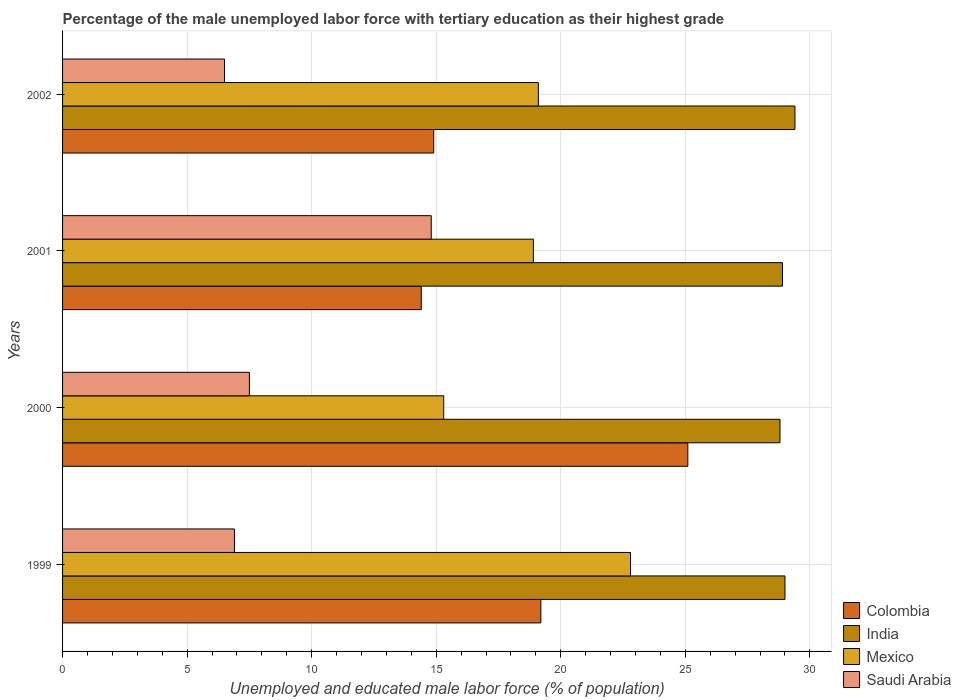Are the number of bars on each tick of the Y-axis equal?
Ensure brevity in your answer.  Yes. How many bars are there on the 3rd tick from the top?
Offer a very short reply. 4. How many bars are there on the 4th tick from the bottom?
Offer a very short reply. 4. In how many cases, is the number of bars for a given year not equal to the number of legend labels?
Your answer should be compact. 0. What is the percentage of the unemployed male labor force with tertiary education in India in 2000?
Make the answer very short. 28.8. Across all years, what is the maximum percentage of the unemployed male labor force with tertiary education in Saudi Arabia?
Ensure brevity in your answer.  14.8. Across all years, what is the minimum percentage of the unemployed male labor force with tertiary education in Saudi Arabia?
Offer a terse response. 6.5. In which year was the percentage of the unemployed male labor force with tertiary education in India minimum?
Ensure brevity in your answer.  2000. What is the total percentage of the unemployed male labor force with tertiary education in Colombia in the graph?
Offer a very short reply. 73.6. What is the difference between the percentage of the unemployed male labor force with tertiary education in Mexico in 2001 and that in 2002?
Make the answer very short. -0.2. What is the difference between the percentage of the unemployed male labor force with tertiary education in Colombia in 2000 and the percentage of the unemployed male labor force with tertiary education in India in 1999?
Your answer should be compact. -3.9. What is the average percentage of the unemployed male labor force with tertiary education in Saudi Arabia per year?
Provide a succinct answer. 8.93. In the year 2001, what is the difference between the percentage of the unemployed male labor force with tertiary education in Colombia and percentage of the unemployed male labor force with tertiary education in Saudi Arabia?
Your answer should be compact. -0.4. What is the ratio of the percentage of the unemployed male labor force with tertiary education in India in 2001 to that in 2002?
Your response must be concise. 0.98. Is the percentage of the unemployed male labor force with tertiary education in Saudi Arabia in 1999 less than that in 2000?
Your answer should be compact. Yes. What is the difference between the highest and the second highest percentage of the unemployed male labor force with tertiary education in Colombia?
Keep it short and to the point. 5.9. What is the difference between the highest and the lowest percentage of the unemployed male labor force with tertiary education in Mexico?
Your answer should be compact. 7.5. In how many years, is the percentage of the unemployed male labor force with tertiary education in Colombia greater than the average percentage of the unemployed male labor force with tertiary education in Colombia taken over all years?
Provide a short and direct response. 2. Is the sum of the percentage of the unemployed male labor force with tertiary education in India in 2001 and 2002 greater than the maximum percentage of the unemployed male labor force with tertiary education in Saudi Arabia across all years?
Ensure brevity in your answer.  Yes. Is it the case that in every year, the sum of the percentage of the unemployed male labor force with tertiary education in Mexico and percentage of the unemployed male labor force with tertiary education in Saudi Arabia is greater than the sum of percentage of the unemployed male labor force with tertiary education in Colombia and percentage of the unemployed male labor force with tertiary education in India?
Offer a very short reply. Yes. What does the 3rd bar from the top in 2001 represents?
Provide a short and direct response. India. What does the 1st bar from the bottom in 2001 represents?
Your response must be concise. Colombia. Is it the case that in every year, the sum of the percentage of the unemployed male labor force with tertiary education in Mexico and percentage of the unemployed male labor force with tertiary education in Colombia is greater than the percentage of the unemployed male labor force with tertiary education in Saudi Arabia?
Give a very brief answer. Yes. How many bars are there?
Provide a short and direct response. 16. Are the values on the major ticks of X-axis written in scientific E-notation?
Your answer should be very brief. No. Does the graph contain grids?
Offer a terse response. Yes. How are the legend labels stacked?
Provide a short and direct response. Vertical. What is the title of the graph?
Your answer should be compact. Percentage of the male unemployed labor force with tertiary education as their highest grade. What is the label or title of the X-axis?
Your answer should be very brief. Unemployed and educated male labor force (% of population). What is the label or title of the Y-axis?
Your answer should be very brief. Years. What is the Unemployed and educated male labor force (% of population) in Colombia in 1999?
Provide a short and direct response. 19.2. What is the Unemployed and educated male labor force (% of population) in Mexico in 1999?
Ensure brevity in your answer.  22.8. What is the Unemployed and educated male labor force (% of population) of Saudi Arabia in 1999?
Keep it short and to the point. 6.9. What is the Unemployed and educated male labor force (% of population) in Colombia in 2000?
Your response must be concise. 25.1. What is the Unemployed and educated male labor force (% of population) of India in 2000?
Offer a terse response. 28.8. What is the Unemployed and educated male labor force (% of population) in Mexico in 2000?
Make the answer very short. 15.3. What is the Unemployed and educated male labor force (% of population) in Saudi Arabia in 2000?
Your answer should be compact. 7.5. What is the Unemployed and educated male labor force (% of population) in Colombia in 2001?
Offer a very short reply. 14.4. What is the Unemployed and educated male labor force (% of population) of India in 2001?
Your answer should be very brief. 28.9. What is the Unemployed and educated male labor force (% of population) of Mexico in 2001?
Offer a very short reply. 18.9. What is the Unemployed and educated male labor force (% of population) of Saudi Arabia in 2001?
Offer a terse response. 14.8. What is the Unemployed and educated male labor force (% of population) in Colombia in 2002?
Give a very brief answer. 14.9. What is the Unemployed and educated male labor force (% of population) of India in 2002?
Provide a succinct answer. 29.4. What is the Unemployed and educated male labor force (% of population) in Mexico in 2002?
Keep it short and to the point. 19.1. What is the Unemployed and educated male labor force (% of population) in Saudi Arabia in 2002?
Ensure brevity in your answer.  6.5. Across all years, what is the maximum Unemployed and educated male labor force (% of population) in Colombia?
Give a very brief answer. 25.1. Across all years, what is the maximum Unemployed and educated male labor force (% of population) of India?
Your answer should be compact. 29.4. Across all years, what is the maximum Unemployed and educated male labor force (% of population) of Mexico?
Your answer should be very brief. 22.8. Across all years, what is the maximum Unemployed and educated male labor force (% of population) of Saudi Arabia?
Ensure brevity in your answer.  14.8. Across all years, what is the minimum Unemployed and educated male labor force (% of population) in Colombia?
Provide a short and direct response. 14.4. Across all years, what is the minimum Unemployed and educated male labor force (% of population) of India?
Ensure brevity in your answer.  28.8. Across all years, what is the minimum Unemployed and educated male labor force (% of population) of Mexico?
Ensure brevity in your answer.  15.3. What is the total Unemployed and educated male labor force (% of population) in Colombia in the graph?
Offer a very short reply. 73.6. What is the total Unemployed and educated male labor force (% of population) of India in the graph?
Ensure brevity in your answer.  116.1. What is the total Unemployed and educated male labor force (% of population) in Mexico in the graph?
Ensure brevity in your answer.  76.1. What is the total Unemployed and educated male labor force (% of population) in Saudi Arabia in the graph?
Give a very brief answer. 35.7. What is the difference between the Unemployed and educated male labor force (% of population) in Saudi Arabia in 1999 and that in 2000?
Your answer should be compact. -0.6. What is the difference between the Unemployed and educated male labor force (% of population) in Colombia in 1999 and that in 2001?
Give a very brief answer. 4.8. What is the difference between the Unemployed and educated male labor force (% of population) of India in 1999 and that in 2001?
Provide a short and direct response. 0.1. What is the difference between the Unemployed and educated male labor force (% of population) of Saudi Arabia in 1999 and that in 2001?
Keep it short and to the point. -7.9. What is the difference between the Unemployed and educated male labor force (% of population) in Mexico in 1999 and that in 2002?
Provide a succinct answer. 3.7. What is the difference between the Unemployed and educated male labor force (% of population) of Mexico in 2000 and that in 2001?
Provide a short and direct response. -3.6. What is the difference between the Unemployed and educated male labor force (% of population) of Colombia in 2000 and that in 2002?
Your answer should be compact. 10.2. What is the difference between the Unemployed and educated male labor force (% of population) of India in 2000 and that in 2002?
Offer a terse response. -0.6. What is the difference between the Unemployed and educated male labor force (% of population) of Mexico in 2000 and that in 2002?
Your answer should be very brief. -3.8. What is the difference between the Unemployed and educated male labor force (% of population) in Colombia in 2001 and that in 2002?
Offer a terse response. -0.5. What is the difference between the Unemployed and educated male labor force (% of population) of India in 2001 and that in 2002?
Offer a very short reply. -0.5. What is the difference between the Unemployed and educated male labor force (% of population) of Mexico in 2001 and that in 2002?
Your response must be concise. -0.2. What is the difference between the Unemployed and educated male labor force (% of population) in Saudi Arabia in 2001 and that in 2002?
Your answer should be compact. 8.3. What is the difference between the Unemployed and educated male labor force (% of population) in Colombia in 1999 and the Unemployed and educated male labor force (% of population) in India in 2000?
Your answer should be compact. -9.6. What is the difference between the Unemployed and educated male labor force (% of population) of Colombia in 1999 and the Unemployed and educated male labor force (% of population) of Mexico in 2000?
Offer a terse response. 3.9. What is the difference between the Unemployed and educated male labor force (% of population) of Colombia in 1999 and the Unemployed and educated male labor force (% of population) of Saudi Arabia in 2000?
Keep it short and to the point. 11.7. What is the difference between the Unemployed and educated male labor force (% of population) of India in 1999 and the Unemployed and educated male labor force (% of population) of Mexico in 2000?
Provide a succinct answer. 13.7. What is the difference between the Unemployed and educated male labor force (% of population) in Mexico in 1999 and the Unemployed and educated male labor force (% of population) in Saudi Arabia in 2000?
Make the answer very short. 15.3. What is the difference between the Unemployed and educated male labor force (% of population) of Colombia in 1999 and the Unemployed and educated male labor force (% of population) of India in 2001?
Give a very brief answer. -9.7. What is the difference between the Unemployed and educated male labor force (% of population) of Colombia in 1999 and the Unemployed and educated male labor force (% of population) of Saudi Arabia in 2001?
Your answer should be compact. 4.4. What is the difference between the Unemployed and educated male labor force (% of population) of India in 1999 and the Unemployed and educated male labor force (% of population) of Mexico in 2001?
Offer a terse response. 10.1. What is the difference between the Unemployed and educated male labor force (% of population) in Mexico in 1999 and the Unemployed and educated male labor force (% of population) in Saudi Arabia in 2001?
Offer a very short reply. 8. What is the difference between the Unemployed and educated male labor force (% of population) of Colombia in 1999 and the Unemployed and educated male labor force (% of population) of Saudi Arabia in 2002?
Ensure brevity in your answer.  12.7. What is the difference between the Unemployed and educated male labor force (% of population) in India in 1999 and the Unemployed and educated male labor force (% of population) in Mexico in 2002?
Give a very brief answer. 9.9. What is the difference between the Unemployed and educated male labor force (% of population) in Mexico in 1999 and the Unemployed and educated male labor force (% of population) in Saudi Arabia in 2002?
Provide a succinct answer. 16.3. What is the difference between the Unemployed and educated male labor force (% of population) in Colombia in 2000 and the Unemployed and educated male labor force (% of population) in Mexico in 2001?
Give a very brief answer. 6.2. What is the difference between the Unemployed and educated male labor force (% of population) in Mexico in 2000 and the Unemployed and educated male labor force (% of population) in Saudi Arabia in 2001?
Provide a short and direct response. 0.5. What is the difference between the Unemployed and educated male labor force (% of population) in India in 2000 and the Unemployed and educated male labor force (% of population) in Mexico in 2002?
Offer a terse response. 9.7. What is the difference between the Unemployed and educated male labor force (% of population) of India in 2000 and the Unemployed and educated male labor force (% of population) of Saudi Arabia in 2002?
Give a very brief answer. 22.3. What is the difference between the Unemployed and educated male labor force (% of population) of Mexico in 2000 and the Unemployed and educated male labor force (% of population) of Saudi Arabia in 2002?
Give a very brief answer. 8.8. What is the difference between the Unemployed and educated male labor force (% of population) in Colombia in 2001 and the Unemployed and educated male labor force (% of population) in Mexico in 2002?
Provide a short and direct response. -4.7. What is the difference between the Unemployed and educated male labor force (% of population) in India in 2001 and the Unemployed and educated male labor force (% of population) in Saudi Arabia in 2002?
Offer a very short reply. 22.4. What is the difference between the Unemployed and educated male labor force (% of population) of Mexico in 2001 and the Unemployed and educated male labor force (% of population) of Saudi Arabia in 2002?
Provide a short and direct response. 12.4. What is the average Unemployed and educated male labor force (% of population) of India per year?
Make the answer very short. 29.02. What is the average Unemployed and educated male labor force (% of population) in Mexico per year?
Offer a terse response. 19.02. What is the average Unemployed and educated male labor force (% of population) in Saudi Arabia per year?
Ensure brevity in your answer.  8.93. In the year 1999, what is the difference between the Unemployed and educated male labor force (% of population) of Colombia and Unemployed and educated male labor force (% of population) of India?
Give a very brief answer. -9.8. In the year 1999, what is the difference between the Unemployed and educated male labor force (% of population) in Colombia and Unemployed and educated male labor force (% of population) in Saudi Arabia?
Provide a short and direct response. 12.3. In the year 1999, what is the difference between the Unemployed and educated male labor force (% of population) of India and Unemployed and educated male labor force (% of population) of Saudi Arabia?
Offer a terse response. 22.1. In the year 2000, what is the difference between the Unemployed and educated male labor force (% of population) of Colombia and Unemployed and educated male labor force (% of population) of Saudi Arabia?
Your response must be concise. 17.6. In the year 2000, what is the difference between the Unemployed and educated male labor force (% of population) in India and Unemployed and educated male labor force (% of population) in Saudi Arabia?
Your answer should be very brief. 21.3. In the year 2002, what is the difference between the Unemployed and educated male labor force (% of population) in Colombia and Unemployed and educated male labor force (% of population) in India?
Keep it short and to the point. -14.5. In the year 2002, what is the difference between the Unemployed and educated male labor force (% of population) of Colombia and Unemployed and educated male labor force (% of population) of Mexico?
Your answer should be very brief. -4.2. In the year 2002, what is the difference between the Unemployed and educated male labor force (% of population) in Colombia and Unemployed and educated male labor force (% of population) in Saudi Arabia?
Provide a succinct answer. 8.4. In the year 2002, what is the difference between the Unemployed and educated male labor force (% of population) of India and Unemployed and educated male labor force (% of population) of Mexico?
Your answer should be compact. 10.3. In the year 2002, what is the difference between the Unemployed and educated male labor force (% of population) in India and Unemployed and educated male labor force (% of population) in Saudi Arabia?
Your answer should be compact. 22.9. In the year 2002, what is the difference between the Unemployed and educated male labor force (% of population) in Mexico and Unemployed and educated male labor force (% of population) in Saudi Arabia?
Keep it short and to the point. 12.6. What is the ratio of the Unemployed and educated male labor force (% of population) of Colombia in 1999 to that in 2000?
Offer a terse response. 0.76. What is the ratio of the Unemployed and educated male labor force (% of population) in Mexico in 1999 to that in 2000?
Provide a short and direct response. 1.49. What is the ratio of the Unemployed and educated male labor force (% of population) of Colombia in 1999 to that in 2001?
Keep it short and to the point. 1.33. What is the ratio of the Unemployed and educated male labor force (% of population) of Mexico in 1999 to that in 2001?
Ensure brevity in your answer.  1.21. What is the ratio of the Unemployed and educated male labor force (% of population) in Saudi Arabia in 1999 to that in 2001?
Make the answer very short. 0.47. What is the ratio of the Unemployed and educated male labor force (% of population) of Colombia in 1999 to that in 2002?
Offer a terse response. 1.29. What is the ratio of the Unemployed and educated male labor force (% of population) in India in 1999 to that in 2002?
Make the answer very short. 0.99. What is the ratio of the Unemployed and educated male labor force (% of population) of Mexico in 1999 to that in 2002?
Keep it short and to the point. 1.19. What is the ratio of the Unemployed and educated male labor force (% of population) in Saudi Arabia in 1999 to that in 2002?
Offer a terse response. 1.06. What is the ratio of the Unemployed and educated male labor force (% of population) in Colombia in 2000 to that in 2001?
Keep it short and to the point. 1.74. What is the ratio of the Unemployed and educated male labor force (% of population) of India in 2000 to that in 2001?
Your answer should be very brief. 1. What is the ratio of the Unemployed and educated male labor force (% of population) of Mexico in 2000 to that in 2001?
Your answer should be very brief. 0.81. What is the ratio of the Unemployed and educated male labor force (% of population) of Saudi Arabia in 2000 to that in 2001?
Offer a terse response. 0.51. What is the ratio of the Unemployed and educated male labor force (% of population) in Colombia in 2000 to that in 2002?
Offer a terse response. 1.68. What is the ratio of the Unemployed and educated male labor force (% of population) of India in 2000 to that in 2002?
Your answer should be compact. 0.98. What is the ratio of the Unemployed and educated male labor force (% of population) of Mexico in 2000 to that in 2002?
Keep it short and to the point. 0.8. What is the ratio of the Unemployed and educated male labor force (% of population) of Saudi Arabia in 2000 to that in 2002?
Your answer should be compact. 1.15. What is the ratio of the Unemployed and educated male labor force (% of population) in Colombia in 2001 to that in 2002?
Provide a short and direct response. 0.97. What is the ratio of the Unemployed and educated male labor force (% of population) of India in 2001 to that in 2002?
Provide a short and direct response. 0.98. What is the ratio of the Unemployed and educated male labor force (% of population) in Mexico in 2001 to that in 2002?
Offer a terse response. 0.99. What is the ratio of the Unemployed and educated male labor force (% of population) of Saudi Arabia in 2001 to that in 2002?
Provide a short and direct response. 2.28. What is the difference between the highest and the second highest Unemployed and educated male labor force (% of population) of Colombia?
Offer a terse response. 5.9. What is the difference between the highest and the second highest Unemployed and educated male labor force (% of population) in India?
Provide a short and direct response. 0.4. What is the difference between the highest and the lowest Unemployed and educated male labor force (% of population) of Mexico?
Keep it short and to the point. 7.5. What is the difference between the highest and the lowest Unemployed and educated male labor force (% of population) in Saudi Arabia?
Your answer should be very brief. 8.3. 